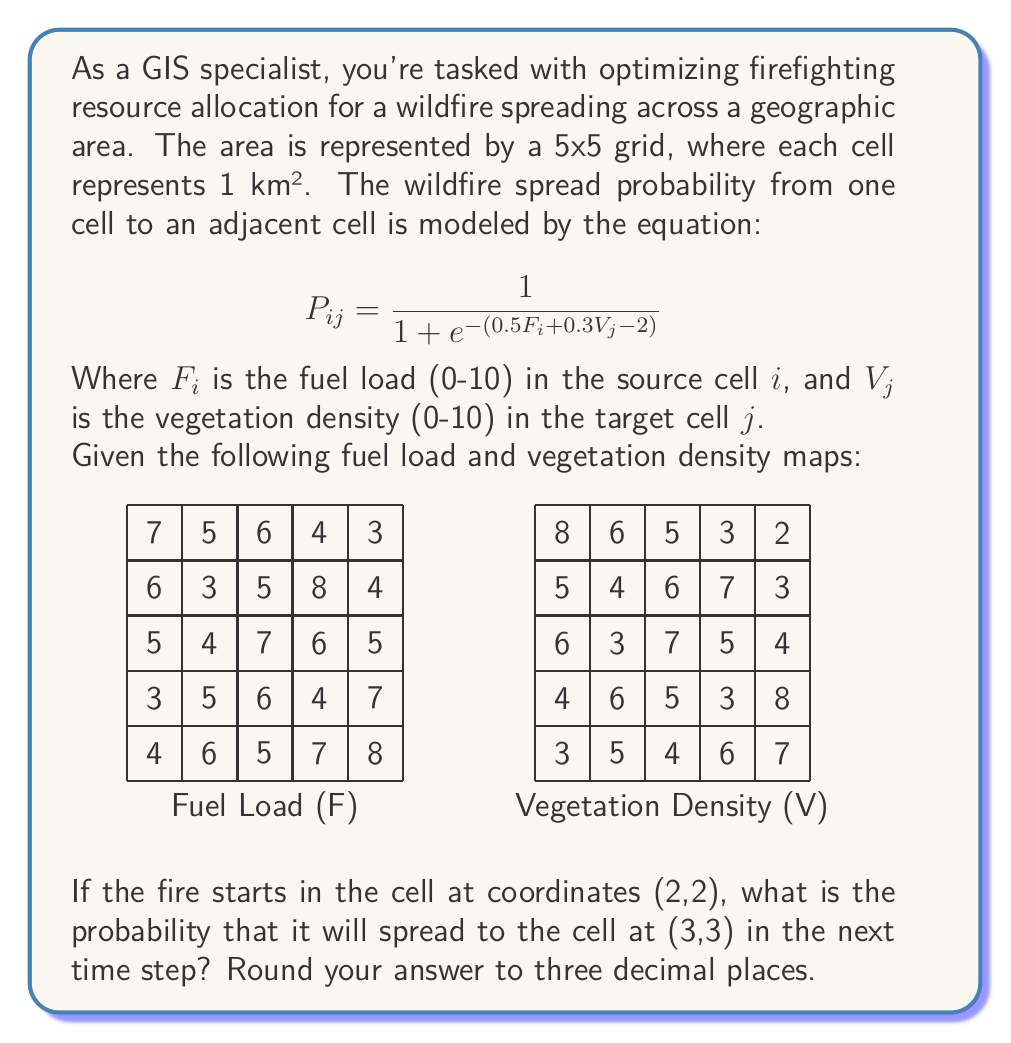Can you solve this math problem? To solve this problem, we need to follow these steps:

1. Identify the fuel load (F) in the source cell (2,2) and the vegetation density (V) in the target cell (3,3).
2. Apply these values to the given probability equation.
3. Calculate the result and round to three decimal places.

Step 1: Identifying the values
- The fuel load F in the source cell (2,2) is 7.
- The vegetation density V in the target cell (3,3) is 7.

Step 2: Applying the values to the equation
We use the equation:

$$P_{ij} = \frac{1}{1 + e^{-(0.5F_i + 0.3V_j - 2)}}$$

Substituting our values:

$$P_{ij} = \frac{1}{1 + e^{-(0.5(7) + 0.3(7) - 2)}}$$

Step 3: Calculating the result
Let's break this down further:

$$P_{ij} = \frac{1}{1 + e^{-(3.5 + 2.1 - 2)}}$$
$$P_{ij} = \frac{1}{1 + e^{-3.6}}$$

Now, let's calculate $e^{-3.6}$:
$e^{-3.6} \approx 0.0273$

Substituting this back into our equation:

$$P_{ij} = \frac{1}{1 + 0.0273} \approx 0.9734$$

Rounding to three decimal places, we get 0.973.
Answer: 0.973 